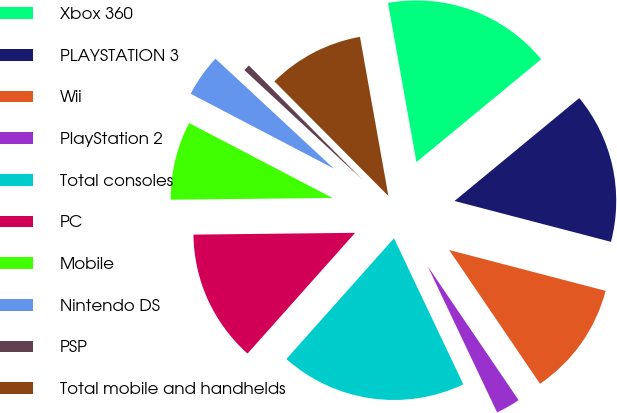Convert chart to OTSL. <chart><loc_0><loc_0><loc_500><loc_500><pie_chart><fcel>Xbox 360<fcel>PLAYSTATION 3<fcel>Wii<fcel>PlayStation 2<fcel>Total consoles<fcel>PC<fcel>Mobile<fcel>Nintendo DS<fcel>PSP<fcel>Total mobile and handhelds<nl><fcel>16.84%<fcel>15.04%<fcel>11.44%<fcel>2.44%<fcel>18.64%<fcel>13.24%<fcel>7.84%<fcel>4.24%<fcel>0.64%<fcel>9.64%<nl></chart> 